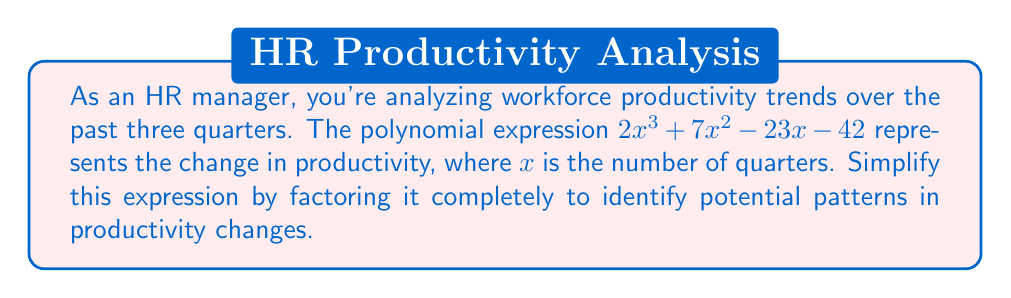Give your solution to this math problem. Let's approach this step-by-step:

1) First, we'll check if there's a greatest common factor (GCF):
   $2x^3 + 7x^2 - 23x - 42$
   There is no common factor, so we proceed to the next step.

2) This is a cubic polynomial. Let's try the rational root theorem to find potential factors. The possible rational roots are the factors of the constant term 42: ±1, ±2, ±3, ±6, ±7, ±14, ±21, ±42

3) Testing these values, we find that -3 is a root. So $(x + 3)$ is a factor.

4) Divide the polynomial by $(x + 3)$:

   $$(2x^3 + 7x^2 - 23x - 42) \div (x + 3) = 2x^2 + x - 14$$

5) Now we have: $2x^3 + 7x^2 - 23x - 42 = (x + 3)(2x^2 + x - 14)$

6) Let's factor the quadratic term $2x^2 + x - 14$:
   
   $a = 2$, $b = 1$, $c = -14$
   
   We're looking for two numbers that multiply to give $ac = -28$ and add to give $b = 1$
   
   These numbers are 7 and -6

7) So, $2x^2 + x - 14 = (2x - 6)(x + 7) = 2(x - 3)(x + 7)$

8) Therefore, the fully factored expression is:

   $2x^3 + 7x^2 - 23x - 42 = (x + 3)(2x - 6)(x + 7) = 2(x + 3)(x - 3)(x + 7)$

This factorization reveals that productivity changes are zero when $x = -3$, $x = 3$, or $x = -7$, corresponding to specific quarter intervals.
Answer: $2(x + 3)(x - 3)(x + 7)$ 